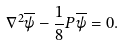<formula> <loc_0><loc_0><loc_500><loc_500>\nabla ^ { 2 } \overline { \psi } - \frac { 1 } { 8 } P \overline { \psi } = 0 .</formula> 